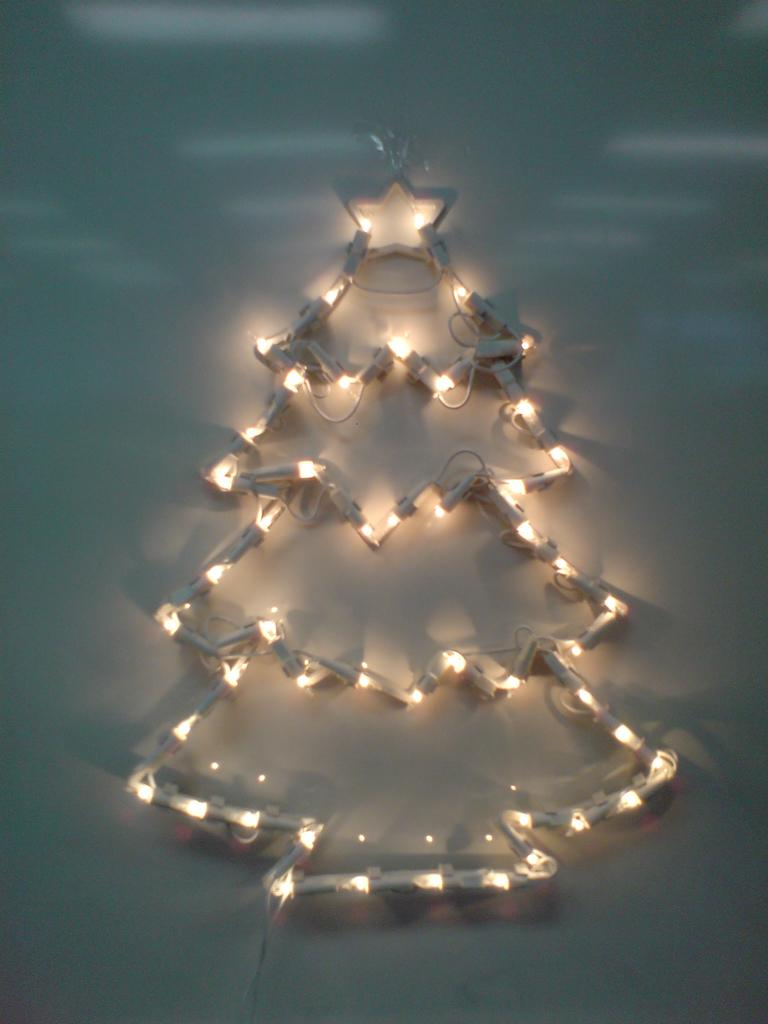What can be seen in the image related to illumination? There are lights in the image. How are the lights arranged in the image? The lights are arranged in the form of a tree. What company is responsible for the approval of the grip on the lights in the image? There is no information about a company or grip on the lights in the image, as it only shows lights arranged in the form of a tree. 